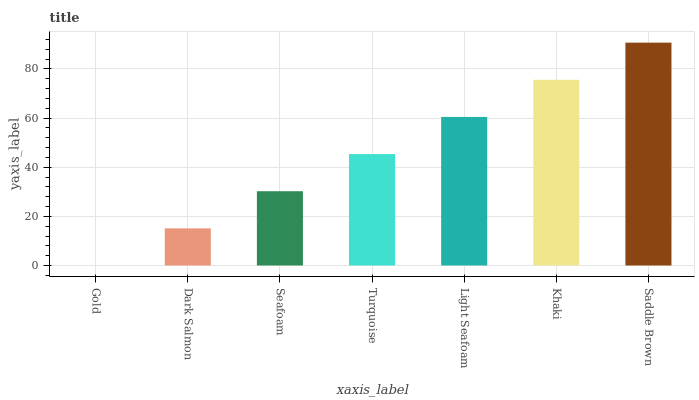Is Dark Salmon the minimum?
Answer yes or no. No. Is Dark Salmon the maximum?
Answer yes or no. No. Is Dark Salmon greater than Gold?
Answer yes or no. Yes. Is Gold less than Dark Salmon?
Answer yes or no. Yes. Is Gold greater than Dark Salmon?
Answer yes or no. No. Is Dark Salmon less than Gold?
Answer yes or no. No. Is Turquoise the high median?
Answer yes or no. Yes. Is Turquoise the low median?
Answer yes or no. Yes. Is Seafoam the high median?
Answer yes or no. No. Is Khaki the low median?
Answer yes or no. No. 